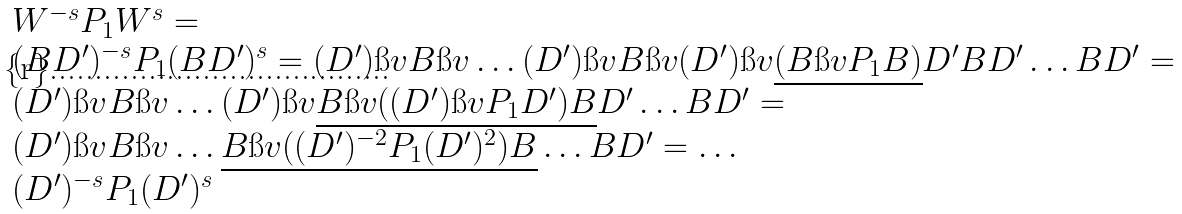Convert formula to latex. <formula><loc_0><loc_0><loc_500><loc_500>\begin{array} { l } W ^ { - s } P _ { 1 } W ^ { s } = \\ ( B D ^ { \prime } ) ^ { - s } P _ { 1 } ( B D ^ { \prime } ) ^ { s } = ( D ^ { \prime } ) \i v B \i v \dots ( D ^ { \prime } ) \i v B \i v ( D ^ { \prime } ) \i v \underline { ( B \i v P _ { 1 } B ) } D ^ { \prime } B D ^ { \prime } \dots B D ^ { \prime } = \\ ( D ^ { \prime } ) \i v B \i v \dots ( D ^ { \prime } ) \i v \underline { B \i v ( ( D ^ { \prime } ) \i v P _ { 1 } D ^ { \prime } ) B } D ^ { \prime } \dots B D ^ { \prime } = \\ ( D ^ { \prime } ) \i v B \i v \dots \underline { B \i v ( ( D ^ { \prime } ) ^ { - 2 } P _ { 1 } ( D ^ { \prime } ) ^ { 2 } ) B } \dots B D ^ { \prime } = \dots \\ ( D ^ { \prime } ) ^ { - s } P _ { 1 } ( D ^ { \prime } ) ^ { s } \end{array}</formula> 